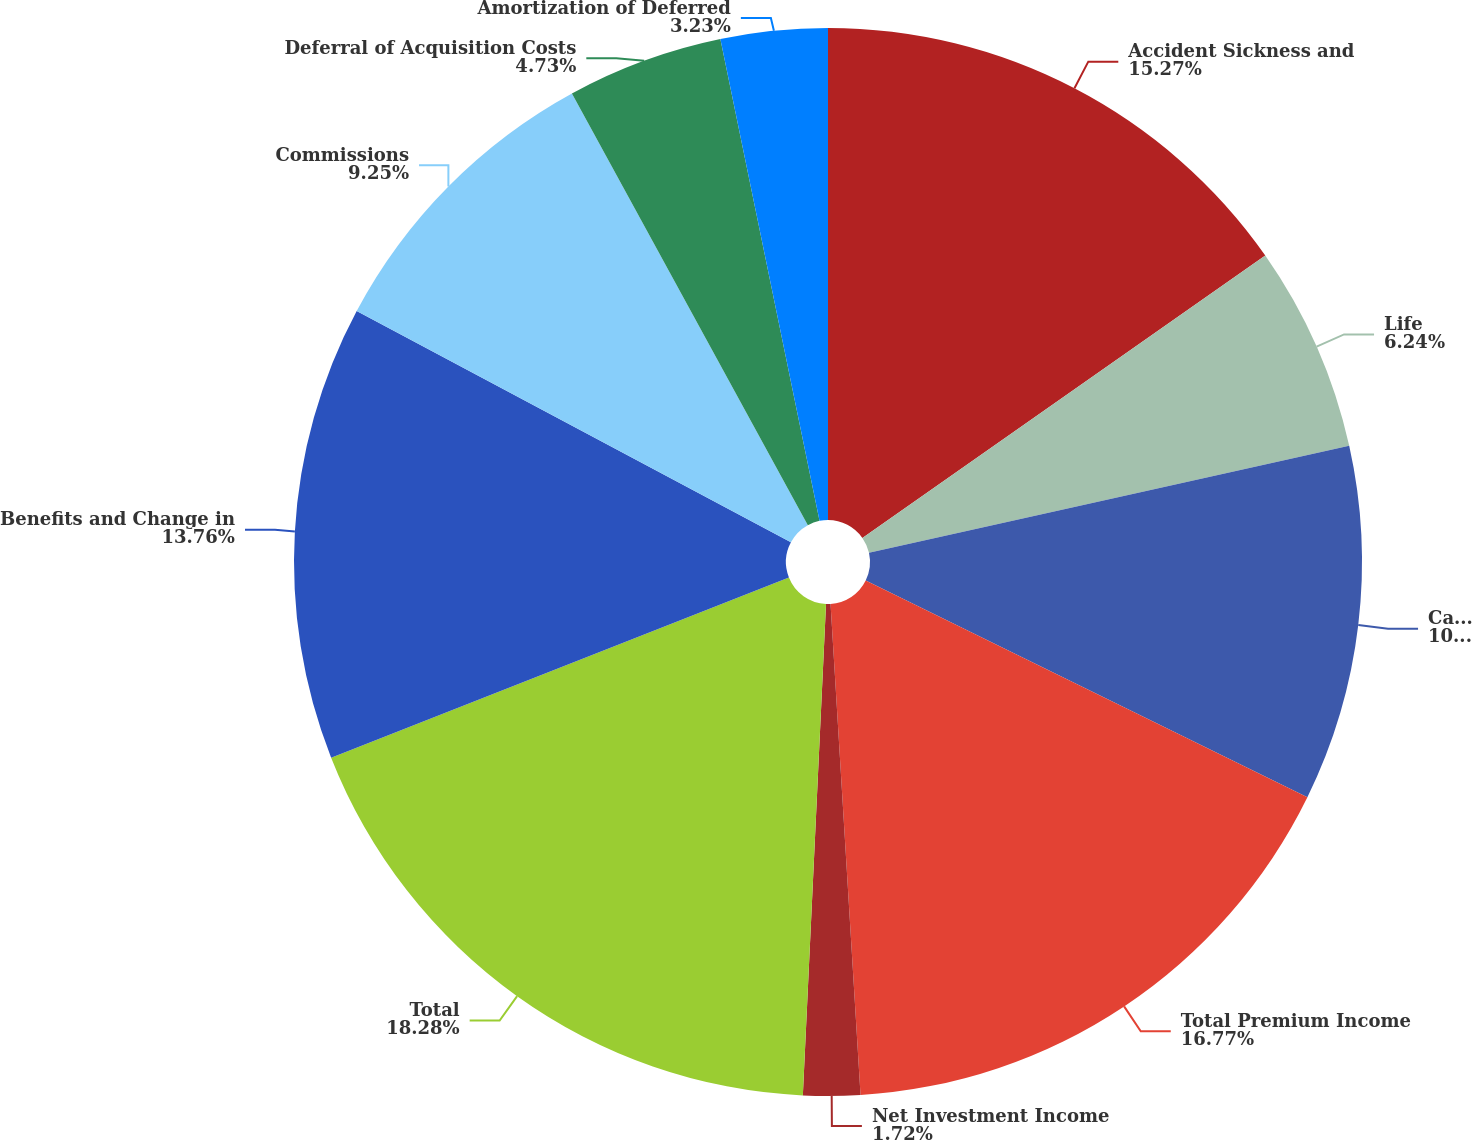<chart> <loc_0><loc_0><loc_500><loc_500><pie_chart><fcel>Accident Sickness and<fcel>Life<fcel>Cancer and Critical Illness<fcel>Total Premium Income<fcel>Net Investment Income<fcel>Total<fcel>Benefits and Change in<fcel>Commissions<fcel>Deferral of Acquisition Costs<fcel>Amortization of Deferred<nl><fcel>15.27%<fcel>6.24%<fcel>10.75%<fcel>16.77%<fcel>1.72%<fcel>18.28%<fcel>13.76%<fcel>9.25%<fcel>4.73%<fcel>3.23%<nl></chart> 